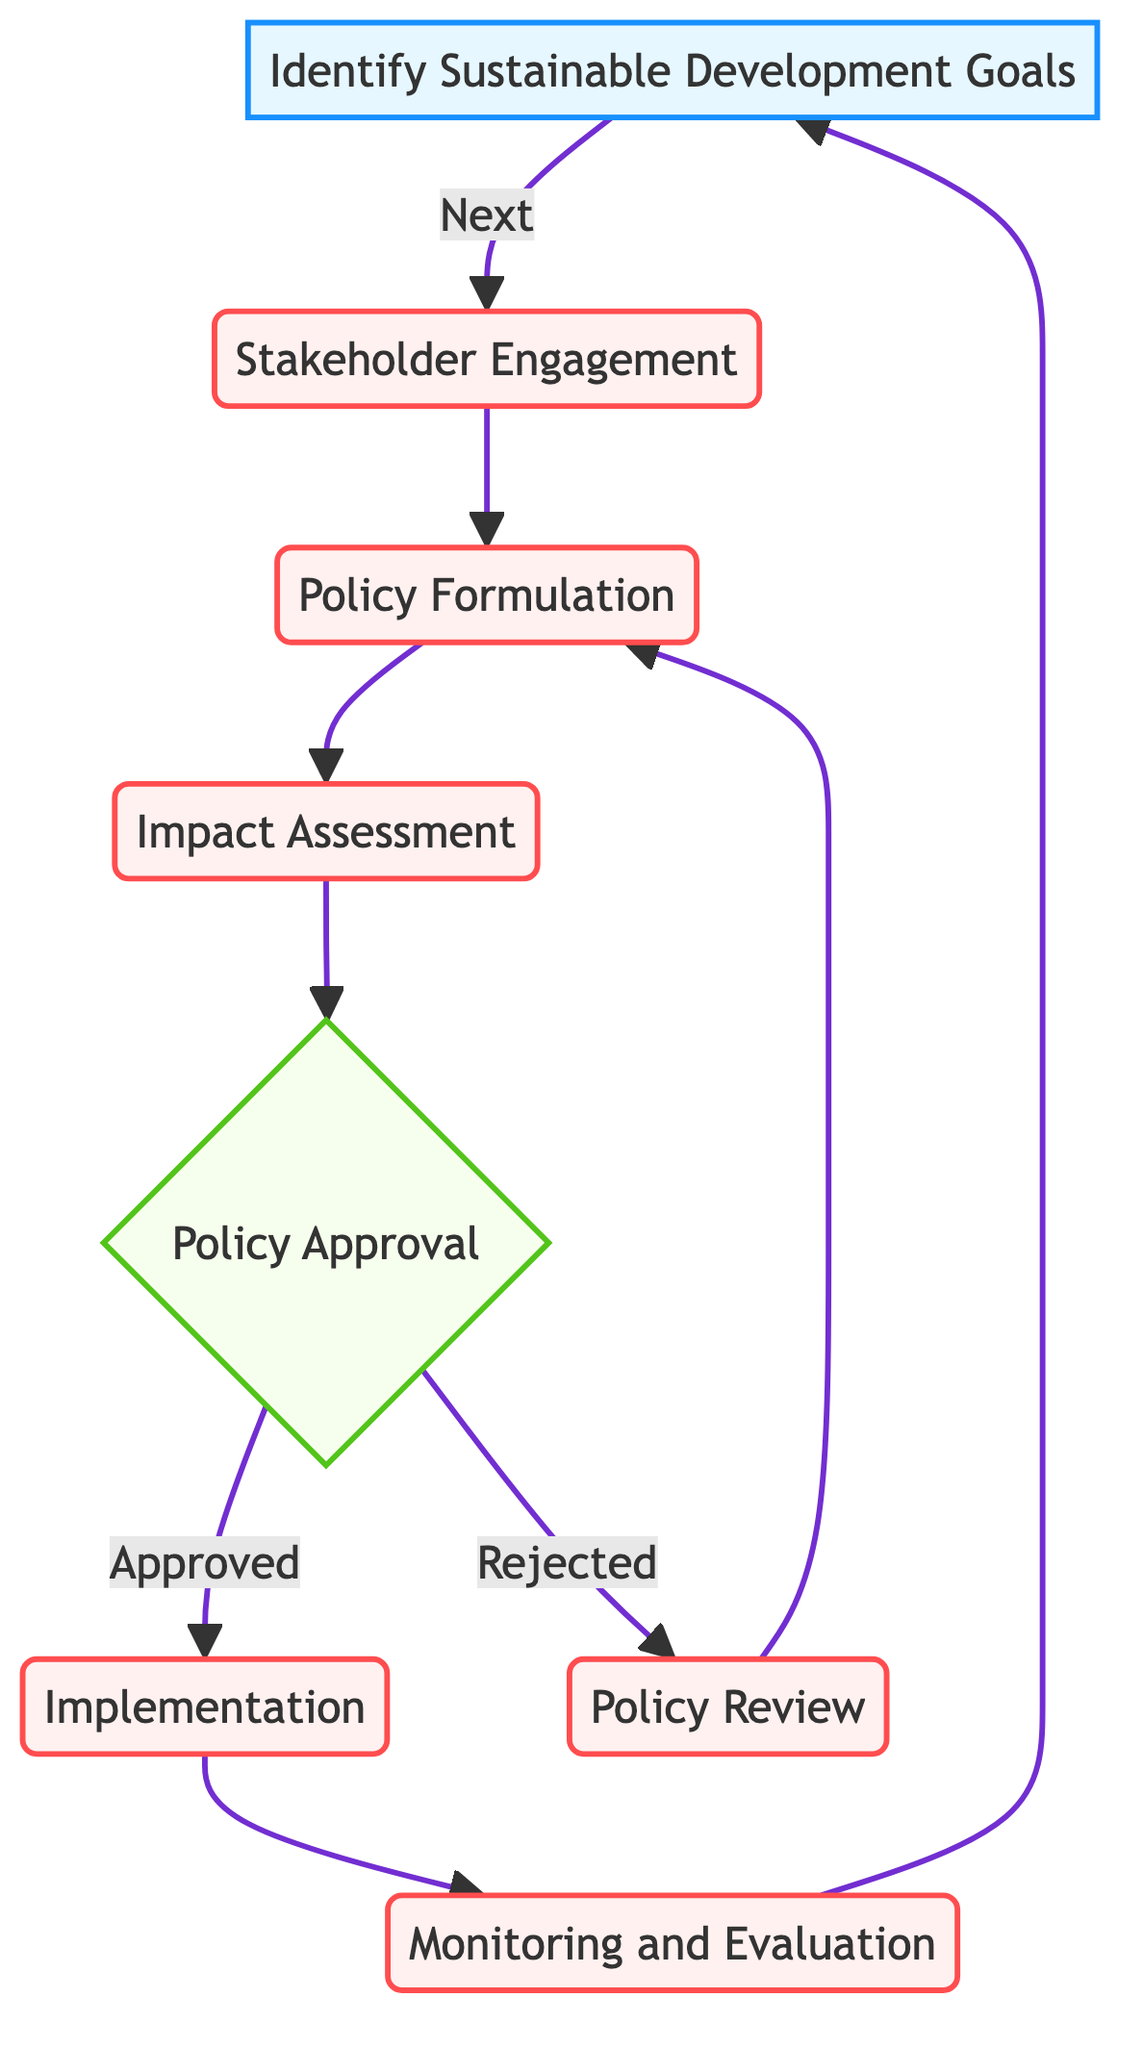What is the first step in the policy decision-making process? The flow chart indicates that the first step is to identify Sustainable Development Goals (SDGs), which serves as the initial input in the process.
Answer: Identify Sustainable Development Goals (SDGs) How many processes are included in the flow chart? The flow chart includes five processes: Stakeholder Engagement, Policy Formulation, Impact Assessment, Policy Review, and Implementation. Counting these, we find there are five processes.
Answer: 5 What happens if the Policy Approval is rejected? According to the diagram, if Policy Approval is rejected, the next step is Policy Review, where the policies will be revisited and refined based on feedback.
Answer: Policy Review What is the final step in the cycle of the diagram? The last step in the flow chart is Monitoring and Evaluation, which leads back to identifying Sustainable Development Goals, completing the cycle.
Answer: Monitoring and Evaluation Which type of node represents Policy Approval? The flow chart indicates that Policy Approval is represented as a decision node, which is denoted by a diamond shape in the diagram.
Answer: Decision What is evaluated during the Impact Assessment stage? The combination of social, economic, and environmental impacts of the proposed policies is evaluated during the Impact Assessment stage, as specified in the flow chart.
Answer: Impacts of proposed policies What is the relationship between Implementation and Monitoring and Evaluation? The flow chart shows a direct flow from Implementation to Monitoring and Evaluation, indicating that Monitoring follows the execution of the approved policies.
Answer: Direct flow What is the purpose of Stakeholder Engagement? The purpose of Stakeholder Engagement is to involve key stakeholders to gather input and gain support for the sustainable development policies being formulated.
Answer: Involve key stakeholders What tool is mentioned for Impact Assessment? The flow chart mentions Environmental Impact Assessments (EIA) and Cost-Benefit Analysis (CBA) as tools used for Impact Assessment.
Answer: Environmental Impact Assessments (EIA) and Cost-Benefit Analysis (CBA) 